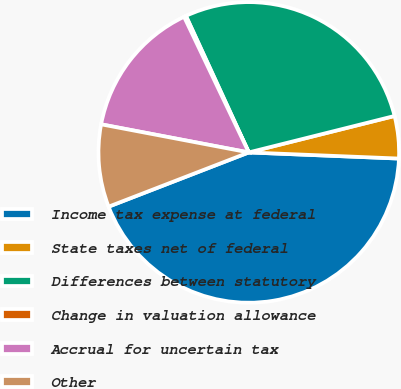<chart> <loc_0><loc_0><loc_500><loc_500><pie_chart><fcel>Income tax expense at federal<fcel>State taxes net of federal<fcel>Differences between statutory<fcel>Change in valuation allowance<fcel>Accrual for uncertain tax<fcel>Other<nl><fcel>43.47%<fcel>4.55%<fcel>27.96%<fcel>0.22%<fcel>14.92%<fcel>8.87%<nl></chart> 